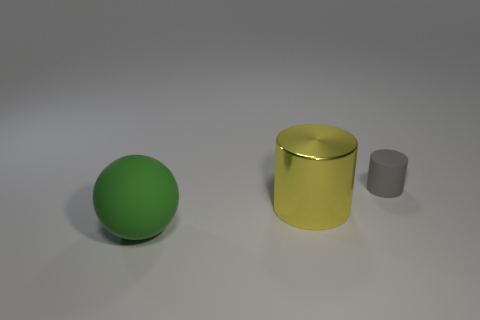Is the material of the small gray thing the same as the big thing that is right of the matte sphere?
Make the answer very short. No. Is there a green thing that has the same material as the large green sphere?
Offer a very short reply. No. How many objects are either matte things that are in front of the gray matte cylinder or matte objects in front of the tiny gray cylinder?
Provide a succinct answer. 1. Is the shape of the yellow metal object the same as the matte thing that is to the left of the large yellow metallic cylinder?
Your answer should be very brief. No. What number of other things are the same shape as the tiny object?
Provide a short and direct response. 1. What number of objects are large gray metal objects or yellow shiny things?
Keep it short and to the point. 1. Is the large shiny thing the same color as the large matte ball?
Your answer should be compact. No. Are there any other things that are the same size as the yellow cylinder?
Offer a terse response. Yes. What shape is the rubber object that is behind the cylinder that is on the left side of the gray matte cylinder?
Offer a terse response. Cylinder. Are there fewer yellow cylinders than small metal things?
Offer a terse response. No. 